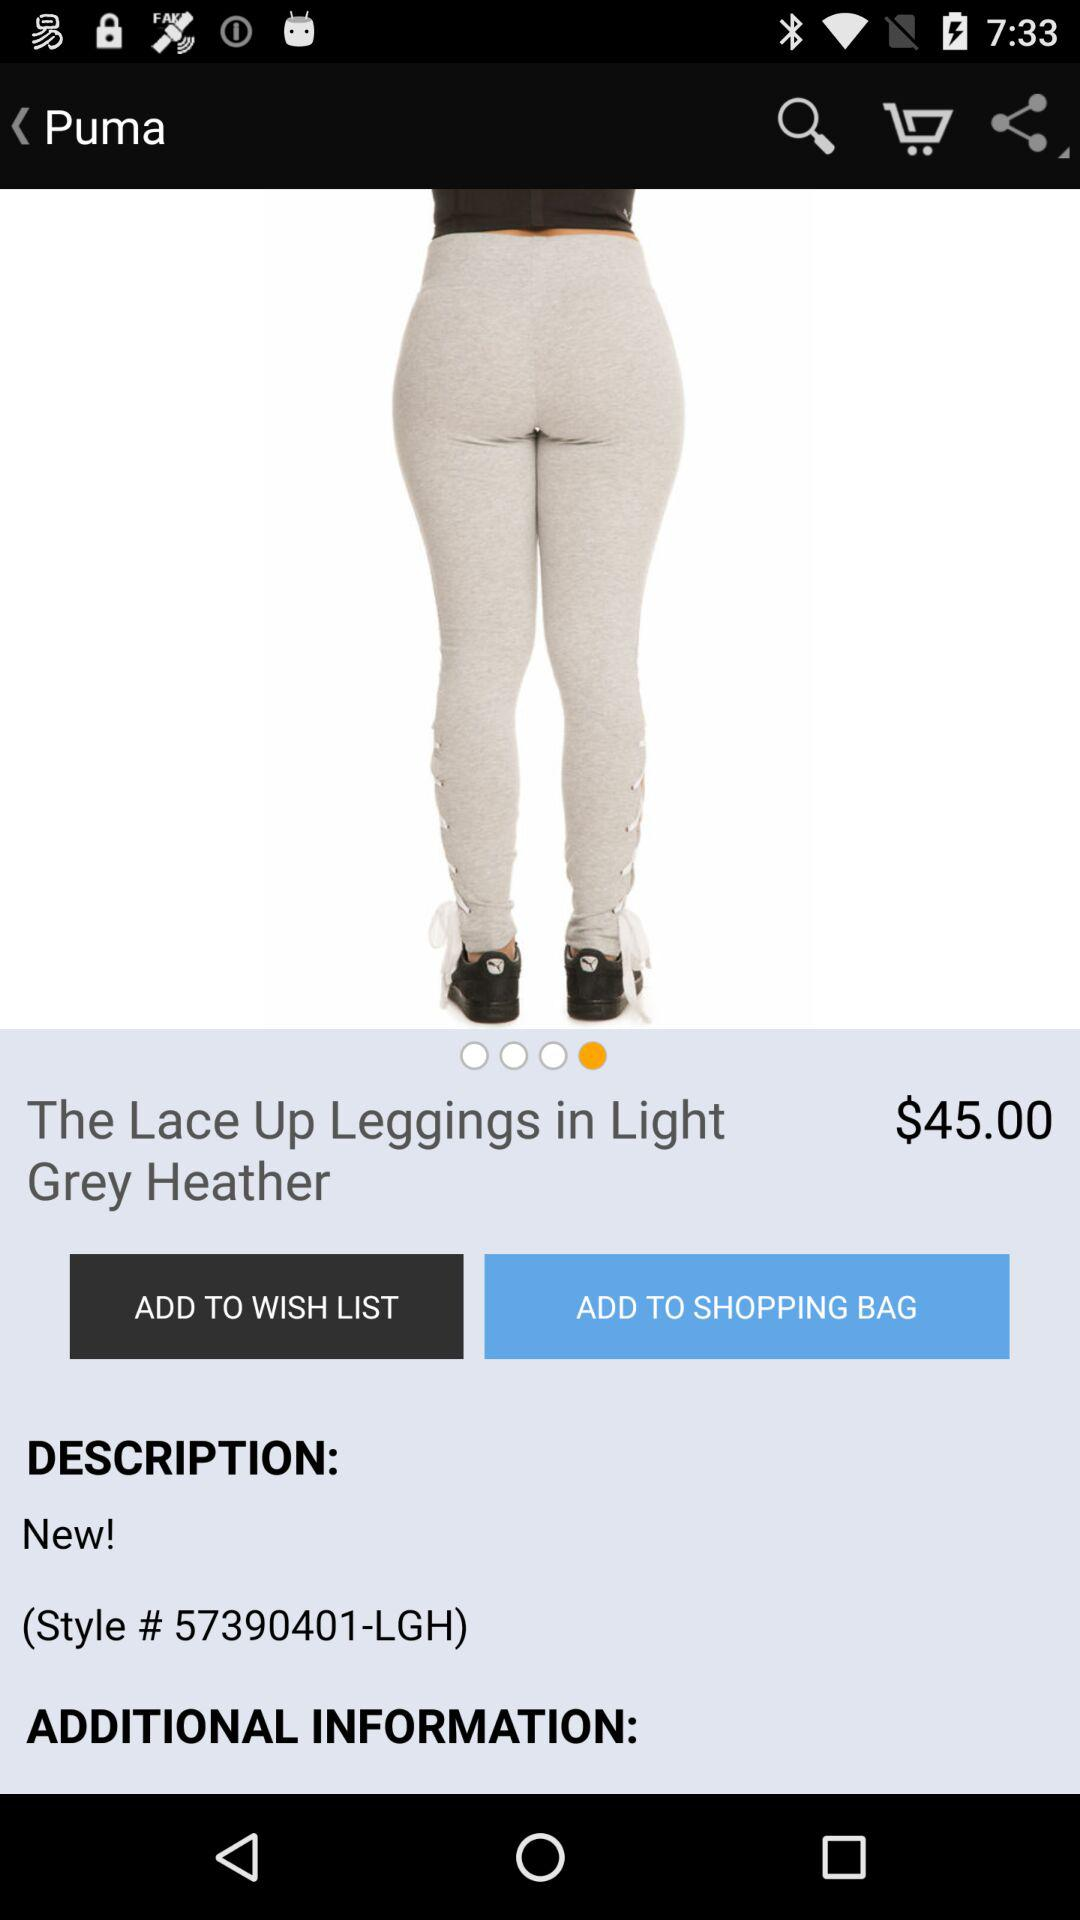What is the price of "The Lace Up Leggings in Light Grey Heather"? The price is $45.00. 